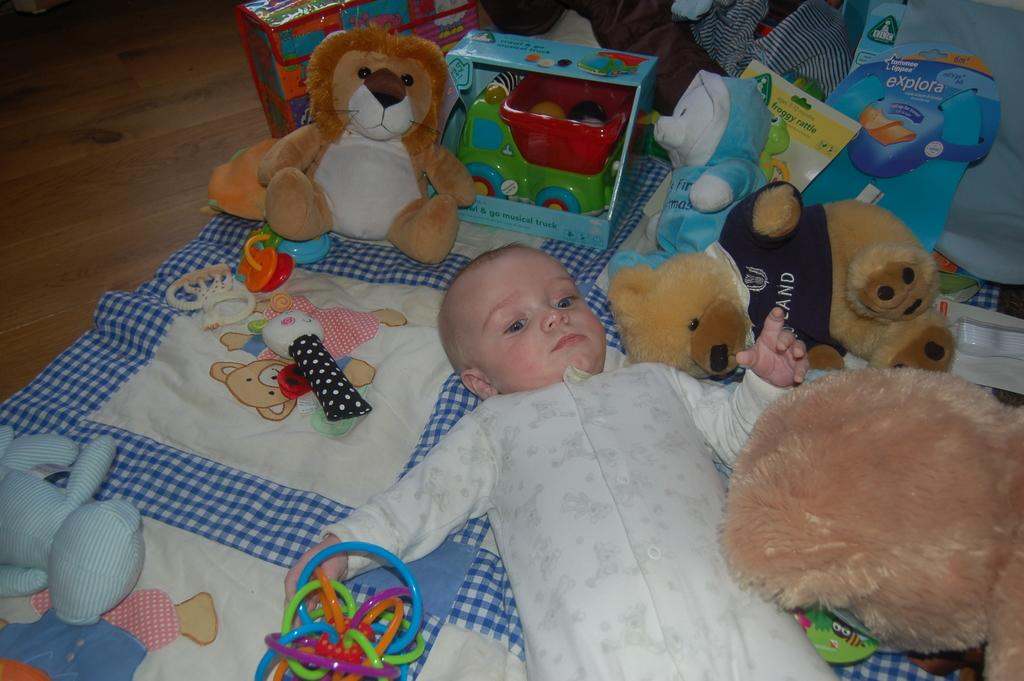What is the kid doing in the image? The kid is lying on the bed in the image. What type of stuffed animals can be seen in the image? There are teddy bears in the image. What other items are present in the image? There are toys and other objects in the image. What type of mask is the kid wearing in the image? There is no mask present in the image; the kid is simply lying on the bed. 